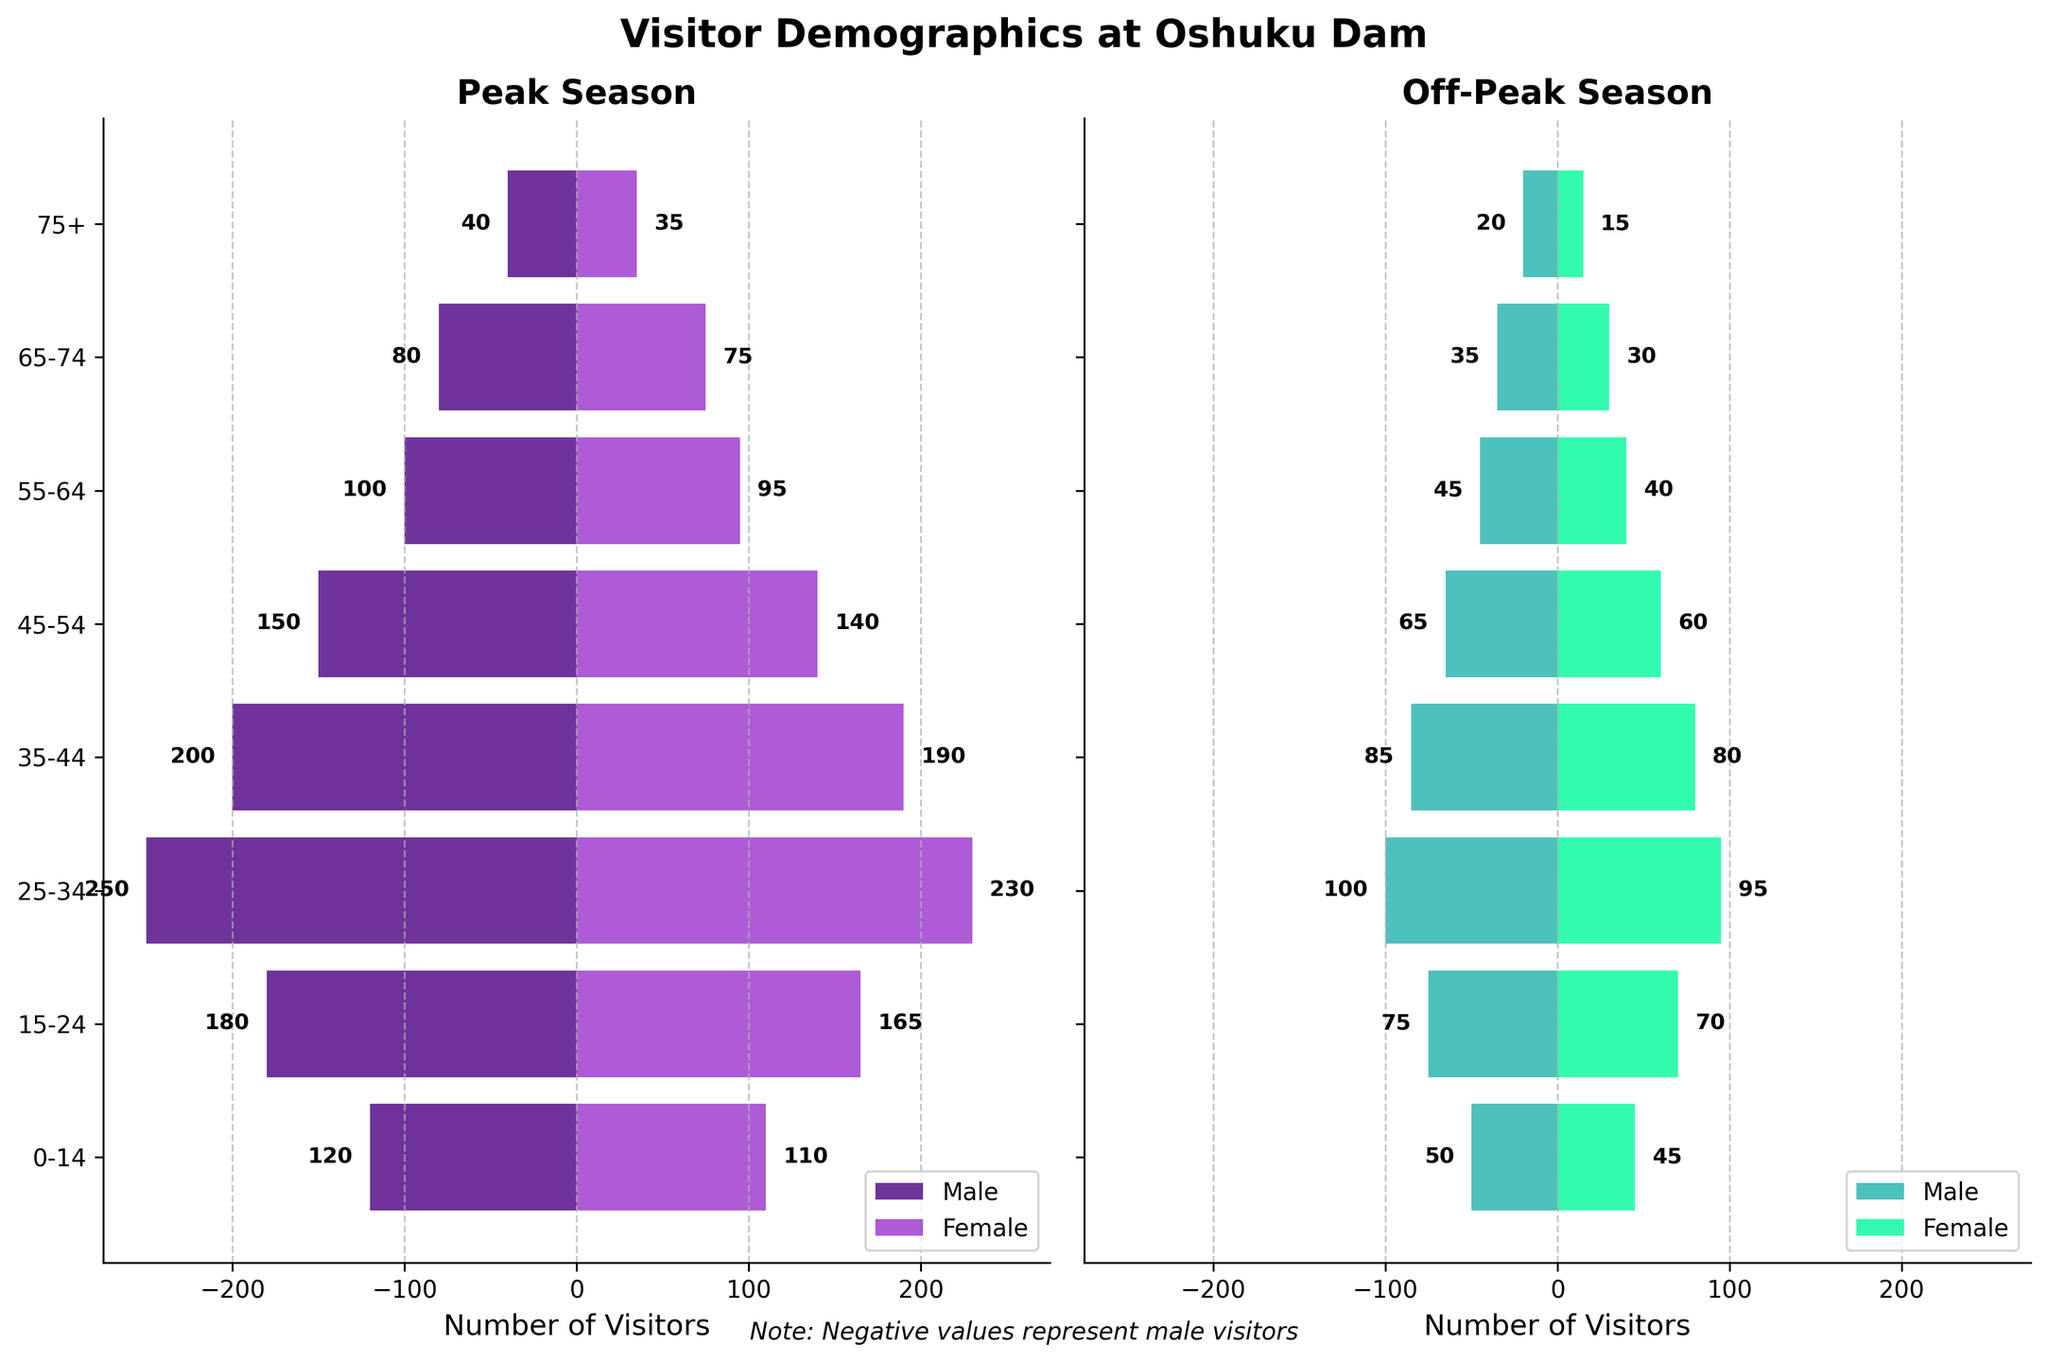What is the title of the figure? The title of the figure is located at the top center and reads "Visitor Demographics at Oshuku Dam."
Answer: Visitor Demographics at Oshuku Dam Which season has more visitors overall? By visually comparing the lengths of the bars in the Peak Season and Off-Peak Season plots, it's clear that the bars are generally longer in the Peak Season plot. This indicates a higher number of visitors in the Peak Season.
Answer: Peak Season In which age group do males peak in visitor number? The longest male bar in the Peak Season plot stretches the furthest to the left, corresponding to the age group "25-34." Therefore, males peak in visitor number in the age group 25-34.
Answer: 25-34 What is the female visitor count for age group 15-24 during the Peak Season? The female bar for the age group 15-24 in the Peak Season stretches to the 165 mark on the x-axis. Hence, there are 165 female visitors in the age group 15-24 during the Peak Season.
Answer: 165 By how much do the number of male visitors in the age group 25-34 differ between Peak and Off-Peak seasons? The number of male visitors for age group 25-34 is 250 in Peak Season and 100 in Off-Peak Season. The difference is calculated as \(250 - 100 = 150\).
Answer: 150 Which gender has more visitors in the age group 35-44 during the Off-Peak Season, and by how much? In the Off-Peak Season, the male visitor count for age group 35-44 is 85, and the female visitor count is 80. Males have 5 more visitors than females.
Answer: Male by 5 How do the number of visitors in the age group 0-14 compare between males and females during the Peak Season? During the Peak Season, males in the 0-14 age group have 120 visitors while females have 110 visitors. Males have 10 more visitors than females.
Answer: Males have 10 more Which age group has the smallest number of visitors during the Off-Peak season? By checking the length of the smallest bars in the Off-Peak Season plot, the age group 75+ has the smallest number of visitors for both males (20) and females (15).
Answer: 75+ What is the total number of female visitors during the Peak Season? Sum up the female visitor counts across all age groups: \(110 + 165 + 230 + 190 + 140 + 95 + 75 + 35 = 1040\).
Answer: 1040 